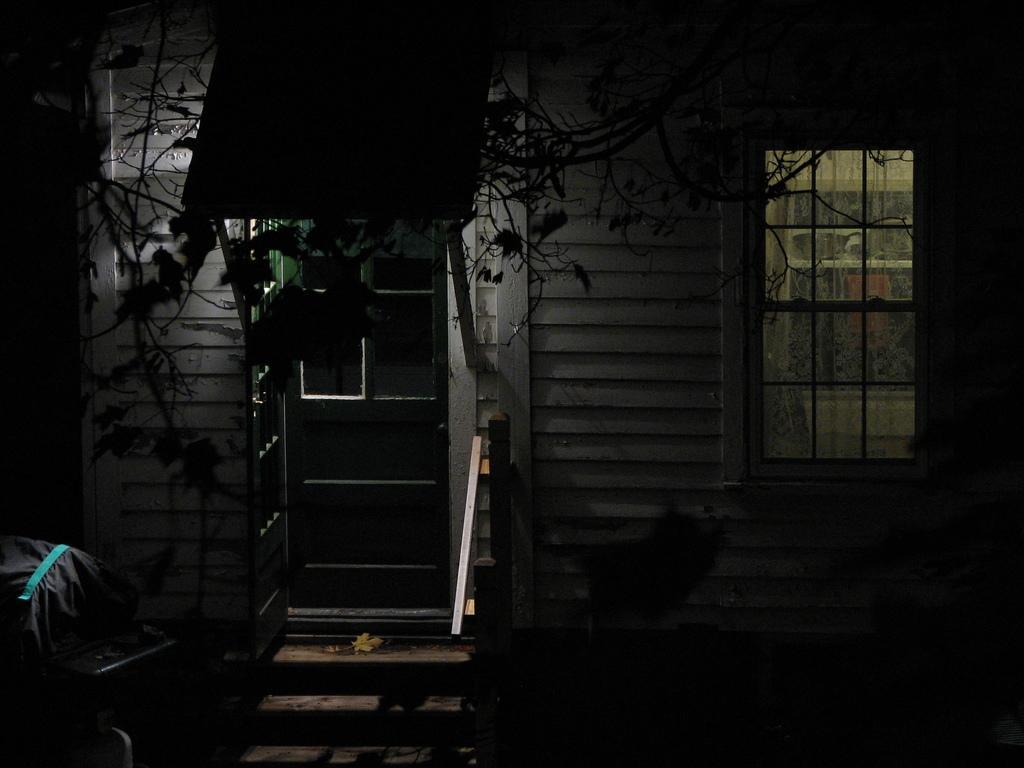Could you give a brief overview of what you see in this image? In this picture I can see a house which has a window, door and steps. I can also see tree and other objects. 